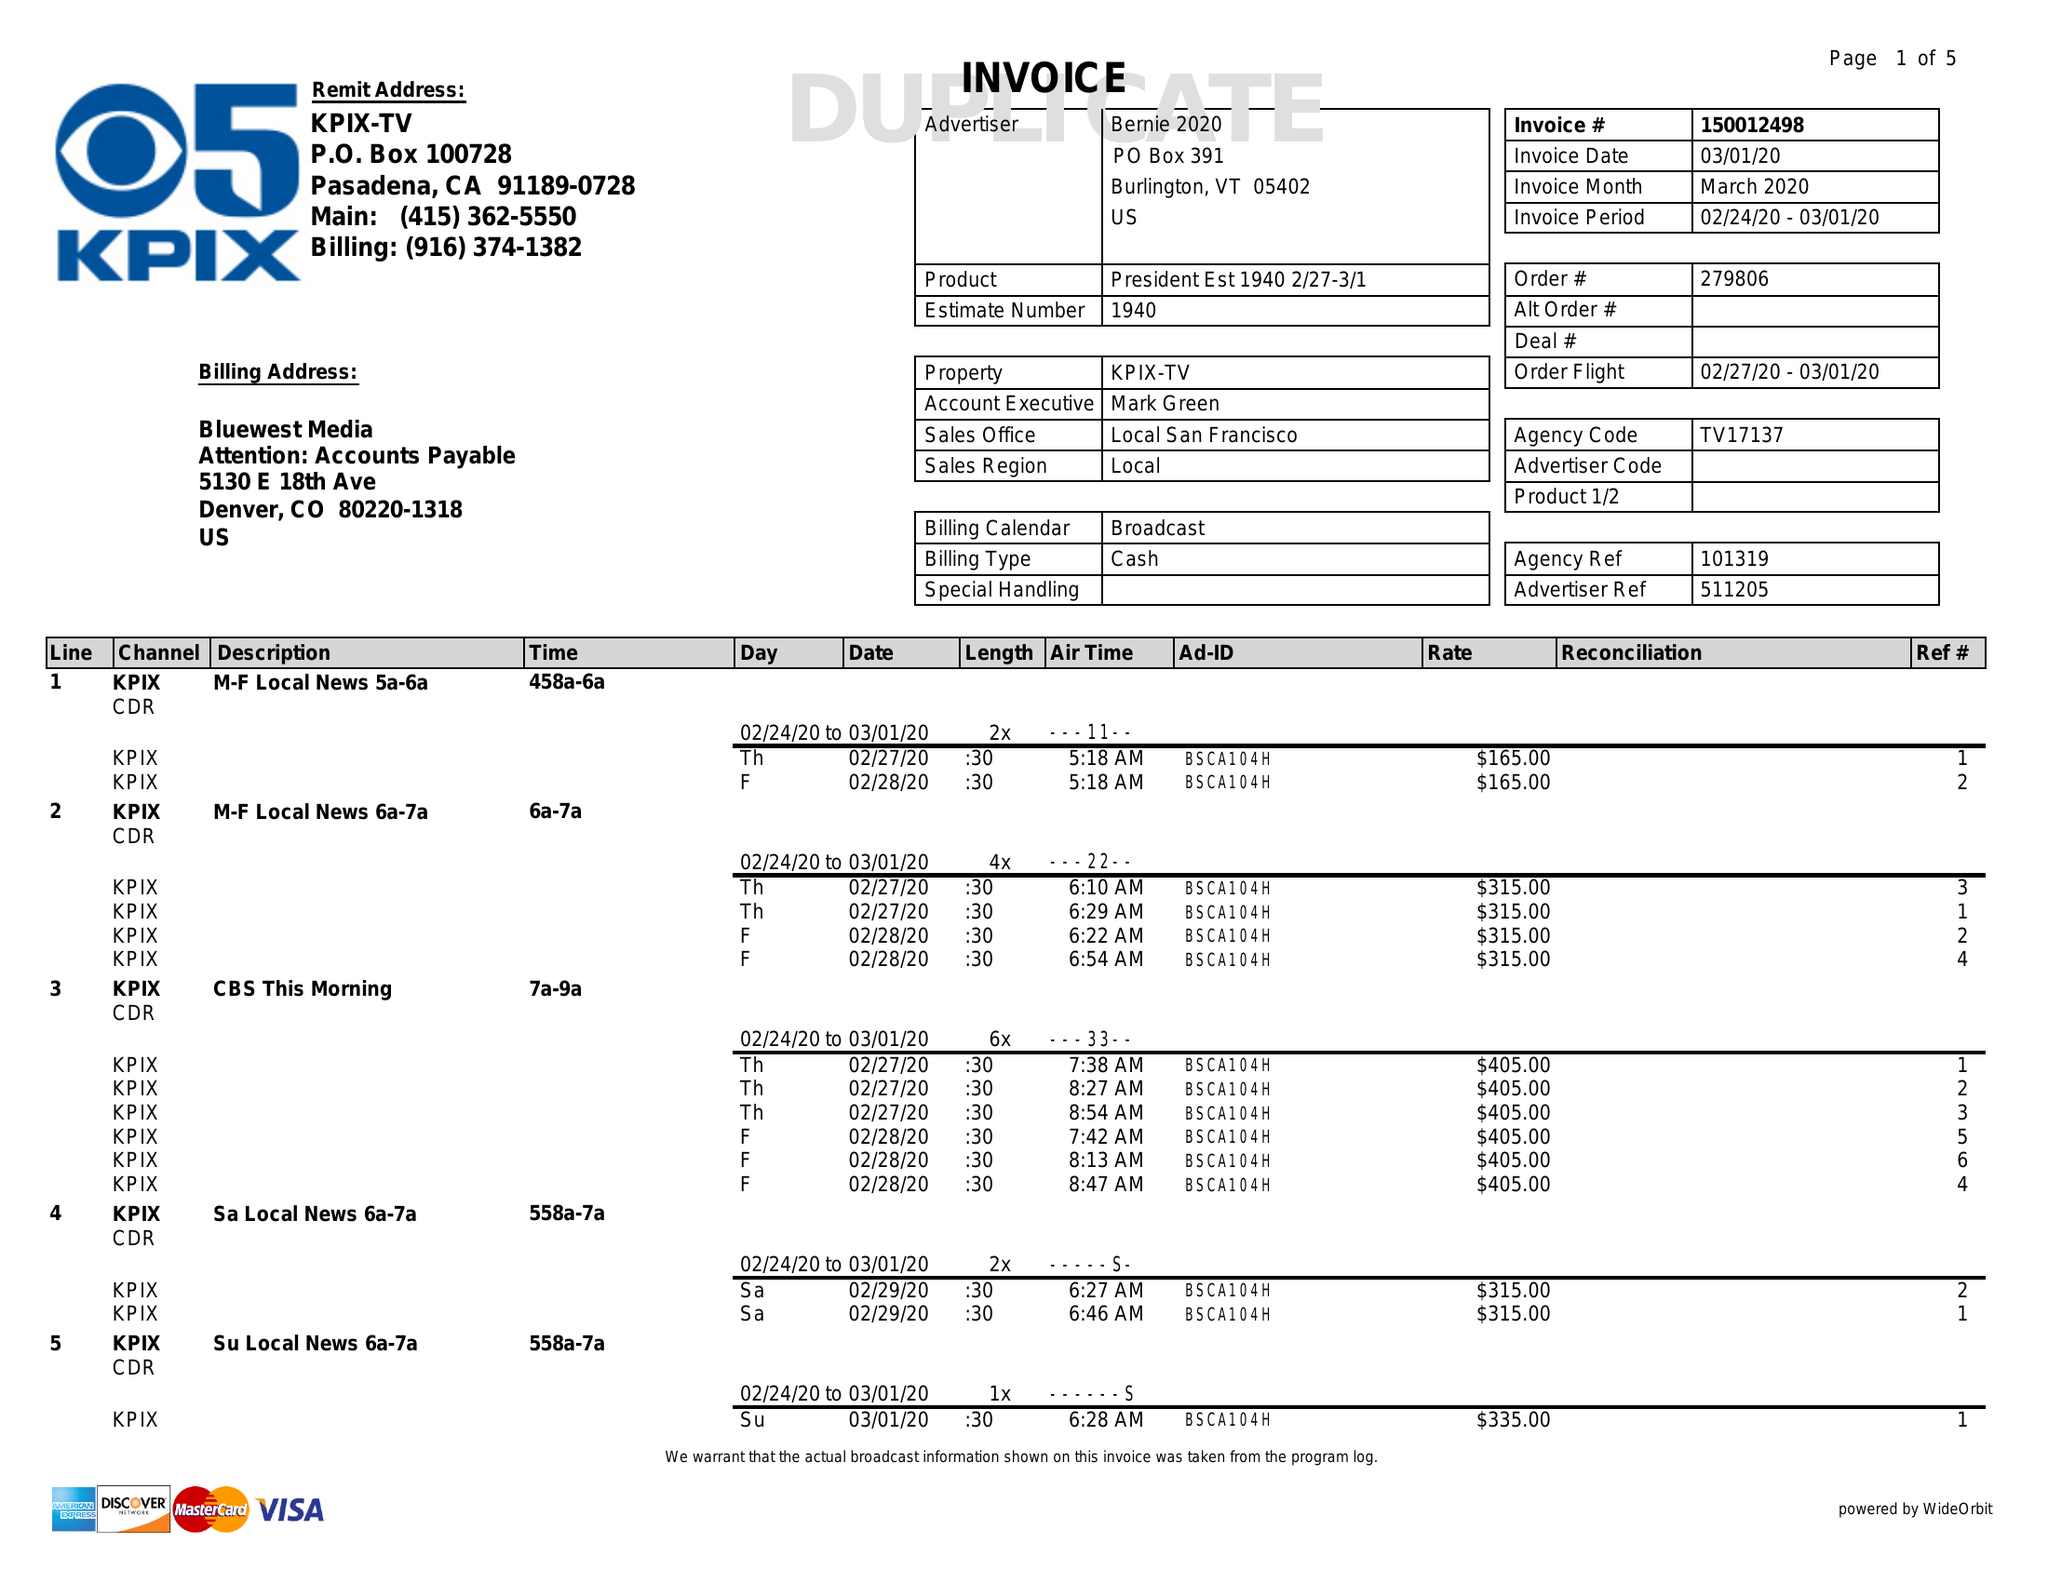What is the value for the flight_from?
Answer the question using a single word or phrase. 02/27/20 